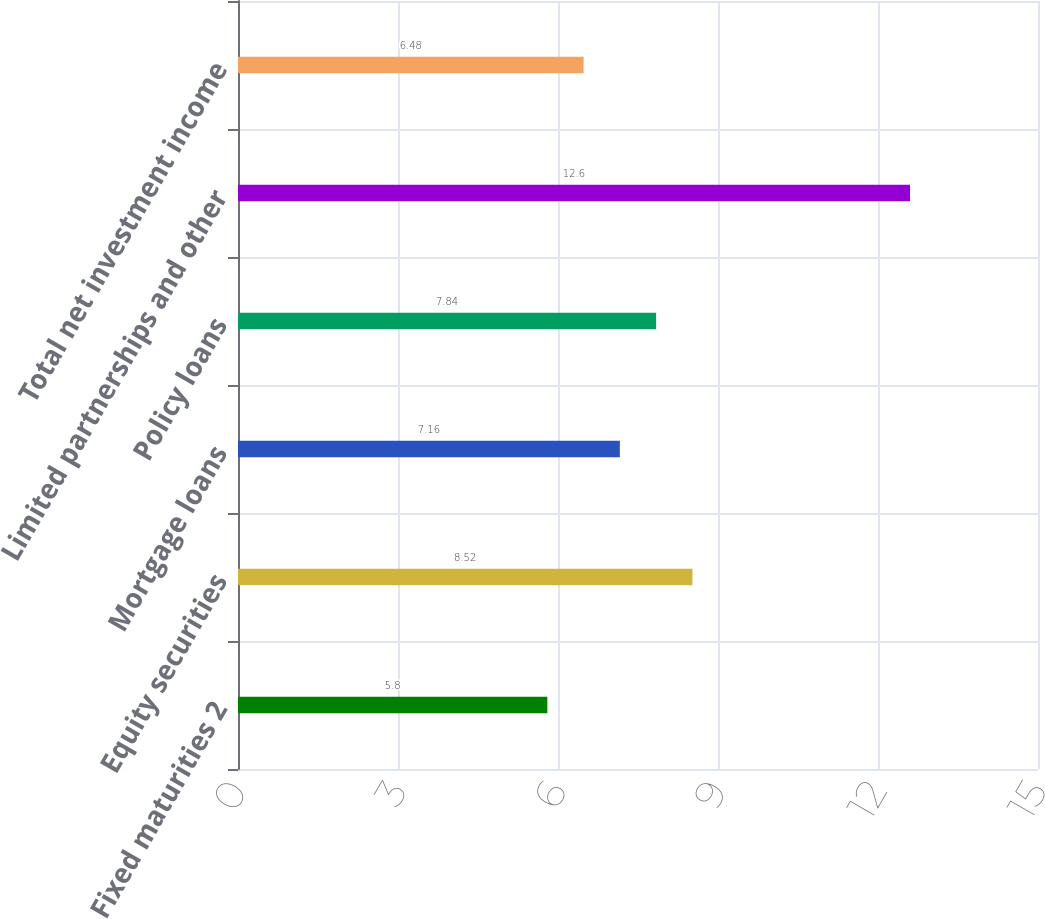<chart> <loc_0><loc_0><loc_500><loc_500><bar_chart><fcel>Fixed maturities 2<fcel>Equity securities<fcel>Mortgage loans<fcel>Policy loans<fcel>Limited partnerships and other<fcel>Total net investment income<nl><fcel>5.8<fcel>8.52<fcel>7.16<fcel>7.84<fcel>12.6<fcel>6.48<nl></chart> 